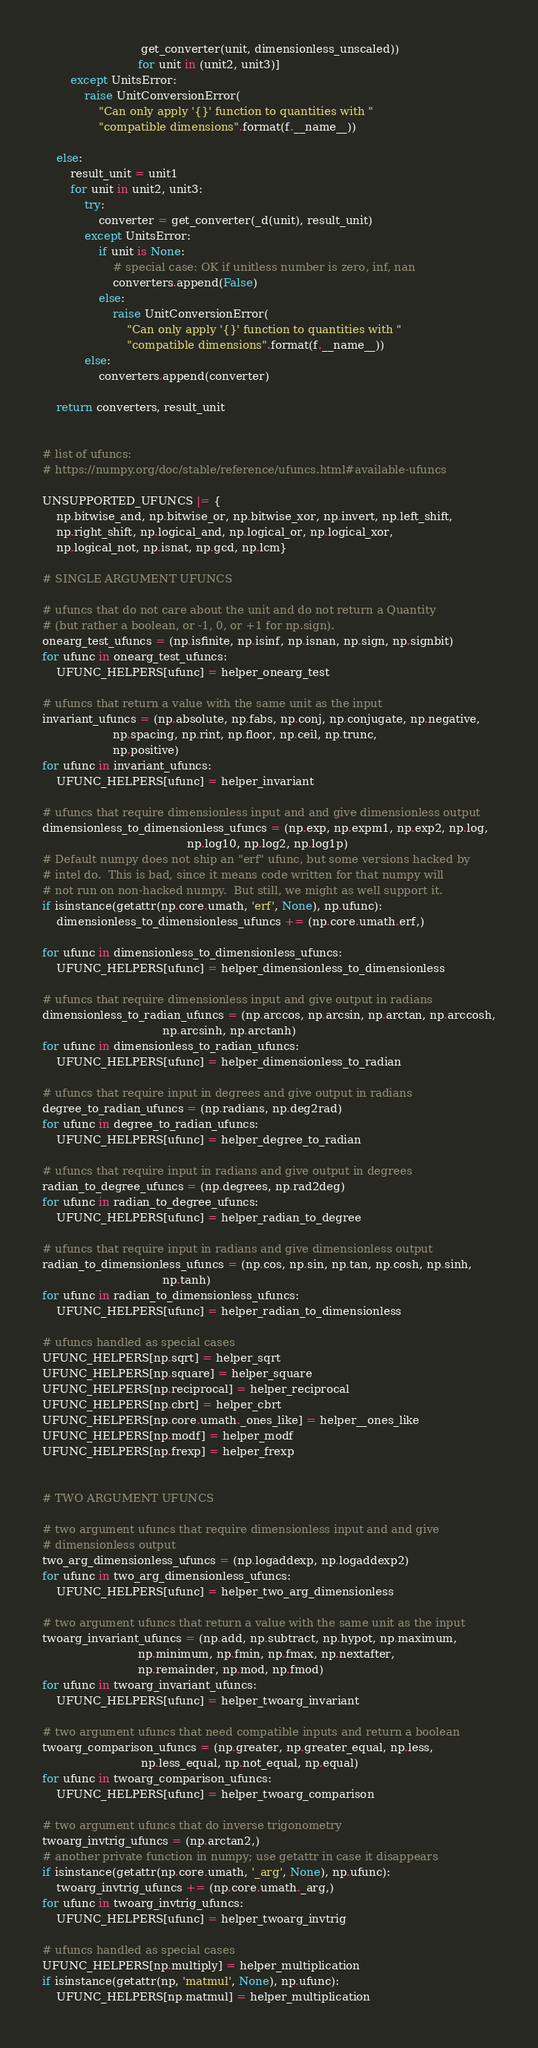Convert code to text. <code><loc_0><loc_0><loc_500><loc_500><_Python_>                            get_converter(unit, dimensionless_unscaled))
                           for unit in (unit2, unit3)]
        except UnitsError:
            raise UnitConversionError(
                "Can only apply '{}' function to quantities with "
                "compatible dimensions".format(f.__name__))

    else:
        result_unit = unit1
        for unit in unit2, unit3:
            try:
                converter = get_converter(_d(unit), result_unit)
            except UnitsError:
                if unit is None:
                    # special case: OK if unitless number is zero, inf, nan
                    converters.append(False)
                else:
                    raise UnitConversionError(
                        "Can only apply '{}' function to quantities with "
                        "compatible dimensions".format(f.__name__))
            else:
                converters.append(converter)

    return converters, result_unit


# list of ufuncs:
# https://numpy.org/doc/stable/reference/ufuncs.html#available-ufuncs

UNSUPPORTED_UFUNCS |= {
    np.bitwise_and, np.bitwise_or, np.bitwise_xor, np.invert, np.left_shift,
    np.right_shift, np.logical_and, np.logical_or, np.logical_xor,
    np.logical_not, np.isnat, np.gcd, np.lcm}

# SINGLE ARGUMENT UFUNCS

# ufuncs that do not care about the unit and do not return a Quantity
# (but rather a boolean, or -1, 0, or +1 for np.sign).
onearg_test_ufuncs = (np.isfinite, np.isinf, np.isnan, np.sign, np.signbit)
for ufunc in onearg_test_ufuncs:
    UFUNC_HELPERS[ufunc] = helper_onearg_test

# ufuncs that return a value with the same unit as the input
invariant_ufuncs = (np.absolute, np.fabs, np.conj, np.conjugate, np.negative,
                    np.spacing, np.rint, np.floor, np.ceil, np.trunc,
                    np.positive)
for ufunc in invariant_ufuncs:
    UFUNC_HELPERS[ufunc] = helper_invariant

# ufuncs that require dimensionless input and and give dimensionless output
dimensionless_to_dimensionless_ufuncs = (np.exp, np.expm1, np.exp2, np.log,
                                         np.log10, np.log2, np.log1p)
# Default numpy does not ship an "erf" ufunc, but some versions hacked by
# intel do.  This is bad, since it means code written for that numpy will
# not run on non-hacked numpy.  But still, we might as well support it.
if isinstance(getattr(np.core.umath, 'erf', None), np.ufunc):
    dimensionless_to_dimensionless_ufuncs += (np.core.umath.erf,)

for ufunc in dimensionless_to_dimensionless_ufuncs:
    UFUNC_HELPERS[ufunc] = helper_dimensionless_to_dimensionless

# ufuncs that require dimensionless input and give output in radians
dimensionless_to_radian_ufuncs = (np.arccos, np.arcsin, np.arctan, np.arccosh,
                                  np.arcsinh, np.arctanh)
for ufunc in dimensionless_to_radian_ufuncs:
    UFUNC_HELPERS[ufunc] = helper_dimensionless_to_radian

# ufuncs that require input in degrees and give output in radians
degree_to_radian_ufuncs = (np.radians, np.deg2rad)
for ufunc in degree_to_radian_ufuncs:
    UFUNC_HELPERS[ufunc] = helper_degree_to_radian

# ufuncs that require input in radians and give output in degrees
radian_to_degree_ufuncs = (np.degrees, np.rad2deg)
for ufunc in radian_to_degree_ufuncs:
    UFUNC_HELPERS[ufunc] = helper_radian_to_degree

# ufuncs that require input in radians and give dimensionless output
radian_to_dimensionless_ufuncs = (np.cos, np.sin, np.tan, np.cosh, np.sinh,
                                  np.tanh)
for ufunc in radian_to_dimensionless_ufuncs:
    UFUNC_HELPERS[ufunc] = helper_radian_to_dimensionless

# ufuncs handled as special cases
UFUNC_HELPERS[np.sqrt] = helper_sqrt
UFUNC_HELPERS[np.square] = helper_square
UFUNC_HELPERS[np.reciprocal] = helper_reciprocal
UFUNC_HELPERS[np.cbrt] = helper_cbrt
UFUNC_HELPERS[np.core.umath._ones_like] = helper__ones_like
UFUNC_HELPERS[np.modf] = helper_modf
UFUNC_HELPERS[np.frexp] = helper_frexp


# TWO ARGUMENT UFUNCS

# two argument ufuncs that require dimensionless input and and give
# dimensionless output
two_arg_dimensionless_ufuncs = (np.logaddexp, np.logaddexp2)
for ufunc in two_arg_dimensionless_ufuncs:
    UFUNC_HELPERS[ufunc] = helper_two_arg_dimensionless

# two argument ufuncs that return a value with the same unit as the input
twoarg_invariant_ufuncs = (np.add, np.subtract, np.hypot, np.maximum,
                           np.minimum, np.fmin, np.fmax, np.nextafter,
                           np.remainder, np.mod, np.fmod)
for ufunc in twoarg_invariant_ufuncs:
    UFUNC_HELPERS[ufunc] = helper_twoarg_invariant

# two argument ufuncs that need compatible inputs and return a boolean
twoarg_comparison_ufuncs = (np.greater, np.greater_equal, np.less,
                            np.less_equal, np.not_equal, np.equal)
for ufunc in twoarg_comparison_ufuncs:
    UFUNC_HELPERS[ufunc] = helper_twoarg_comparison

# two argument ufuncs that do inverse trigonometry
twoarg_invtrig_ufuncs = (np.arctan2,)
# another private function in numpy; use getattr in case it disappears
if isinstance(getattr(np.core.umath, '_arg', None), np.ufunc):
    twoarg_invtrig_ufuncs += (np.core.umath._arg,)
for ufunc in twoarg_invtrig_ufuncs:
    UFUNC_HELPERS[ufunc] = helper_twoarg_invtrig

# ufuncs handled as special cases
UFUNC_HELPERS[np.multiply] = helper_multiplication
if isinstance(getattr(np, 'matmul', None), np.ufunc):
    UFUNC_HELPERS[np.matmul] = helper_multiplication</code> 